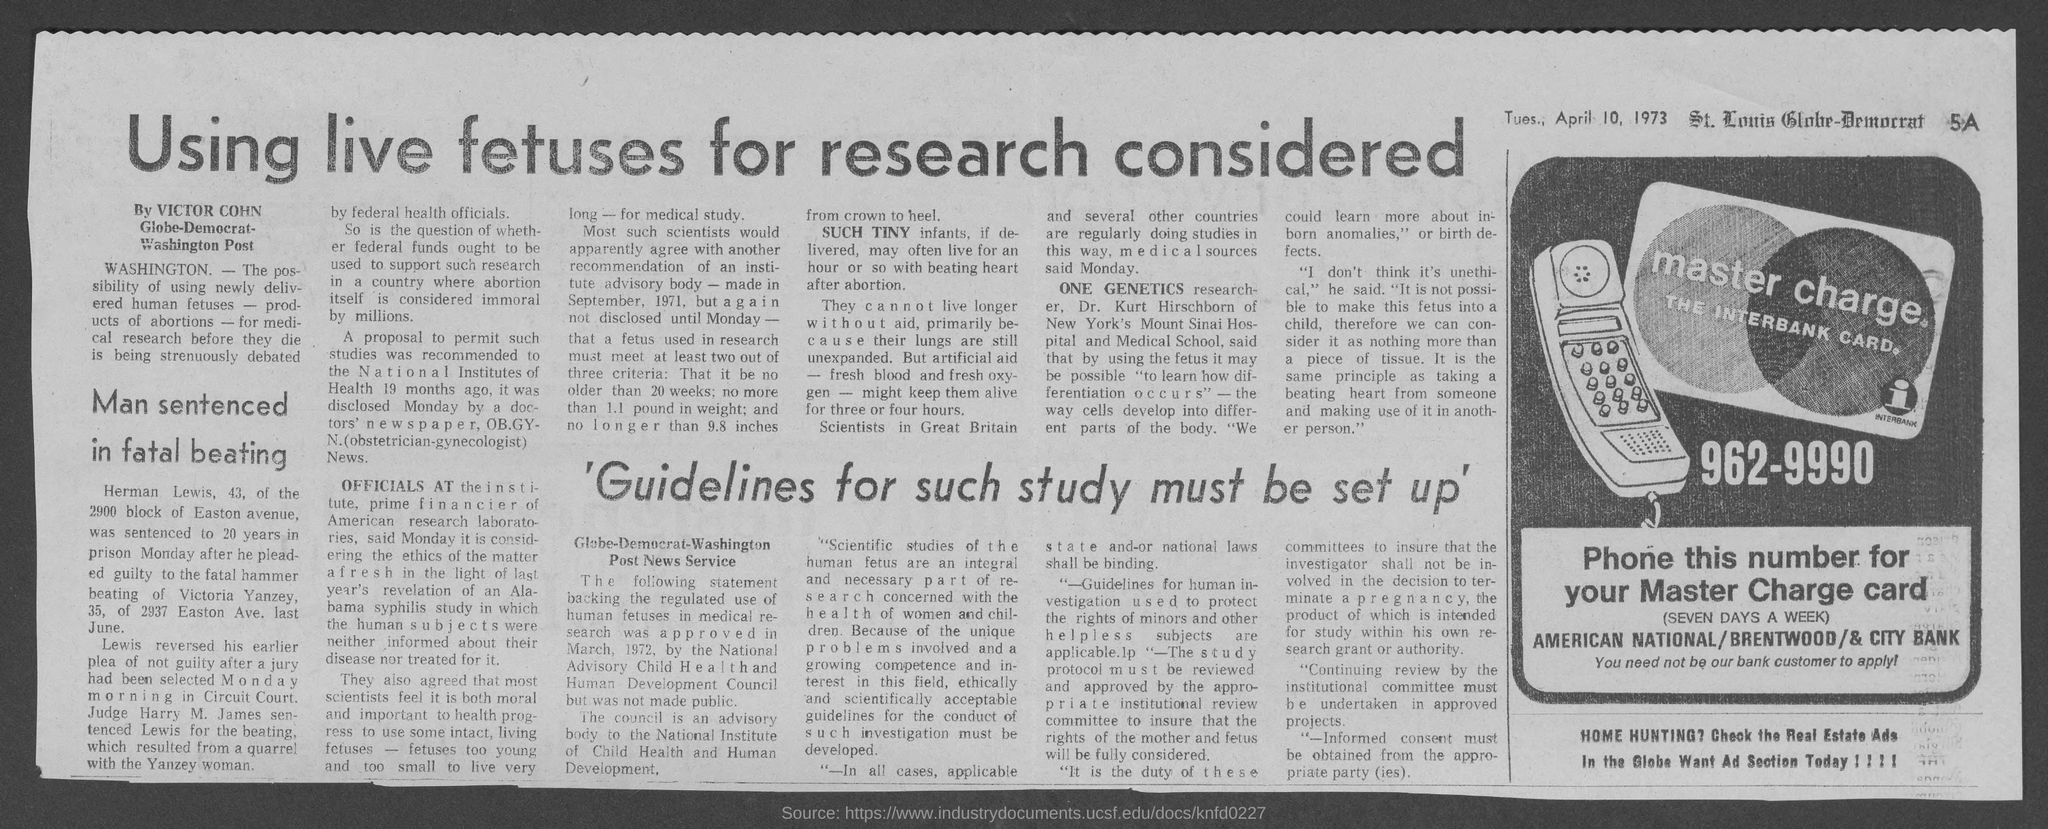What is the Phone number?
Ensure brevity in your answer.  962-9990. What is the date mentioned in the document?
Your answer should be compact. Tues., April 10, 1973. Who writes the article?
Offer a terse response. Victor Cohn. 